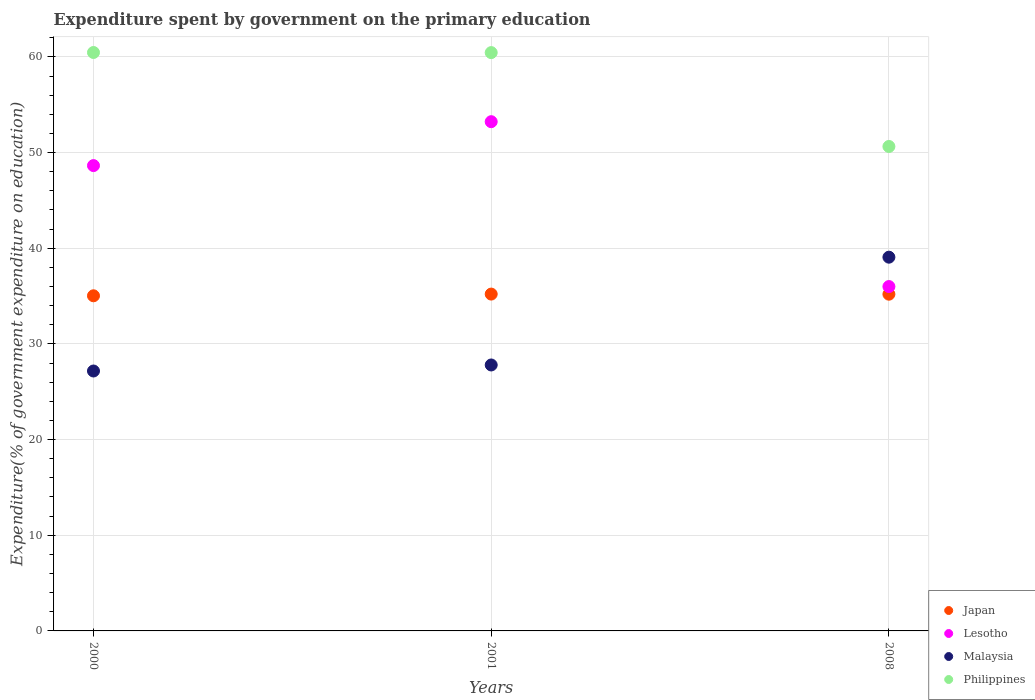Is the number of dotlines equal to the number of legend labels?
Ensure brevity in your answer.  Yes. What is the expenditure spent by government on the primary education in Malaysia in 2001?
Ensure brevity in your answer.  27.8. Across all years, what is the maximum expenditure spent by government on the primary education in Japan?
Offer a terse response. 35.21. Across all years, what is the minimum expenditure spent by government on the primary education in Philippines?
Give a very brief answer. 50.64. What is the total expenditure spent by government on the primary education in Lesotho in the graph?
Your answer should be very brief. 137.86. What is the difference between the expenditure spent by government on the primary education in Lesotho in 2000 and that in 2008?
Ensure brevity in your answer.  12.64. What is the difference between the expenditure spent by government on the primary education in Japan in 2001 and the expenditure spent by government on the primary education in Philippines in 2008?
Keep it short and to the point. -15.43. What is the average expenditure spent by government on the primary education in Lesotho per year?
Give a very brief answer. 45.95. In the year 2008, what is the difference between the expenditure spent by government on the primary education in Japan and expenditure spent by government on the primary education in Philippines?
Make the answer very short. -15.44. In how many years, is the expenditure spent by government on the primary education in Lesotho greater than 2 %?
Provide a short and direct response. 3. What is the ratio of the expenditure spent by government on the primary education in Malaysia in 2001 to that in 2008?
Keep it short and to the point. 0.71. Is the difference between the expenditure spent by government on the primary education in Japan in 2000 and 2008 greater than the difference between the expenditure spent by government on the primary education in Philippines in 2000 and 2008?
Your response must be concise. No. What is the difference between the highest and the second highest expenditure spent by government on the primary education in Japan?
Your answer should be compact. 0.01. What is the difference between the highest and the lowest expenditure spent by government on the primary education in Philippines?
Provide a succinct answer. 9.82. Is the sum of the expenditure spent by government on the primary education in Lesotho in 2001 and 2008 greater than the maximum expenditure spent by government on the primary education in Philippines across all years?
Your answer should be compact. Yes. Is the expenditure spent by government on the primary education in Philippines strictly greater than the expenditure spent by government on the primary education in Lesotho over the years?
Keep it short and to the point. Yes. Is the expenditure spent by government on the primary education in Malaysia strictly less than the expenditure spent by government on the primary education in Philippines over the years?
Your answer should be very brief. Yes. How many dotlines are there?
Your answer should be compact. 4. What is the difference between two consecutive major ticks on the Y-axis?
Your answer should be very brief. 10. Are the values on the major ticks of Y-axis written in scientific E-notation?
Your response must be concise. No. Does the graph contain grids?
Your answer should be compact. Yes. How many legend labels are there?
Provide a short and direct response. 4. What is the title of the graph?
Give a very brief answer. Expenditure spent by government on the primary education. What is the label or title of the X-axis?
Make the answer very short. Years. What is the label or title of the Y-axis?
Your answer should be very brief. Expenditure(% of government expenditure on education). What is the Expenditure(% of government expenditure on education) of Japan in 2000?
Make the answer very short. 35.03. What is the Expenditure(% of government expenditure on education) in Lesotho in 2000?
Provide a short and direct response. 48.64. What is the Expenditure(% of government expenditure on education) of Malaysia in 2000?
Your response must be concise. 27.17. What is the Expenditure(% of government expenditure on education) in Philippines in 2000?
Your answer should be compact. 60.46. What is the Expenditure(% of government expenditure on education) of Japan in 2001?
Offer a very short reply. 35.21. What is the Expenditure(% of government expenditure on education) in Lesotho in 2001?
Make the answer very short. 53.23. What is the Expenditure(% of government expenditure on education) in Malaysia in 2001?
Give a very brief answer. 27.8. What is the Expenditure(% of government expenditure on education) in Philippines in 2001?
Keep it short and to the point. 60.45. What is the Expenditure(% of government expenditure on education) in Japan in 2008?
Your answer should be compact. 35.2. What is the Expenditure(% of government expenditure on education) in Lesotho in 2008?
Give a very brief answer. 35.99. What is the Expenditure(% of government expenditure on education) in Malaysia in 2008?
Provide a short and direct response. 39.06. What is the Expenditure(% of government expenditure on education) in Philippines in 2008?
Provide a succinct answer. 50.64. Across all years, what is the maximum Expenditure(% of government expenditure on education) in Japan?
Provide a short and direct response. 35.21. Across all years, what is the maximum Expenditure(% of government expenditure on education) in Lesotho?
Make the answer very short. 53.23. Across all years, what is the maximum Expenditure(% of government expenditure on education) in Malaysia?
Offer a terse response. 39.06. Across all years, what is the maximum Expenditure(% of government expenditure on education) of Philippines?
Offer a terse response. 60.46. Across all years, what is the minimum Expenditure(% of government expenditure on education) of Japan?
Ensure brevity in your answer.  35.03. Across all years, what is the minimum Expenditure(% of government expenditure on education) in Lesotho?
Provide a succinct answer. 35.99. Across all years, what is the minimum Expenditure(% of government expenditure on education) in Malaysia?
Ensure brevity in your answer.  27.17. Across all years, what is the minimum Expenditure(% of government expenditure on education) of Philippines?
Your answer should be very brief. 50.64. What is the total Expenditure(% of government expenditure on education) of Japan in the graph?
Provide a short and direct response. 105.43. What is the total Expenditure(% of government expenditure on education) in Lesotho in the graph?
Offer a very short reply. 137.86. What is the total Expenditure(% of government expenditure on education) of Malaysia in the graph?
Your response must be concise. 94.03. What is the total Expenditure(% of government expenditure on education) of Philippines in the graph?
Your response must be concise. 171.54. What is the difference between the Expenditure(% of government expenditure on education) in Japan in 2000 and that in 2001?
Your response must be concise. -0.18. What is the difference between the Expenditure(% of government expenditure on education) of Lesotho in 2000 and that in 2001?
Offer a very short reply. -4.59. What is the difference between the Expenditure(% of government expenditure on education) of Malaysia in 2000 and that in 2001?
Your response must be concise. -0.63. What is the difference between the Expenditure(% of government expenditure on education) of Philippines in 2000 and that in 2001?
Ensure brevity in your answer.  0.01. What is the difference between the Expenditure(% of government expenditure on education) of Japan in 2000 and that in 2008?
Offer a terse response. -0.17. What is the difference between the Expenditure(% of government expenditure on education) in Lesotho in 2000 and that in 2008?
Make the answer very short. 12.64. What is the difference between the Expenditure(% of government expenditure on education) in Malaysia in 2000 and that in 2008?
Ensure brevity in your answer.  -11.9. What is the difference between the Expenditure(% of government expenditure on education) in Philippines in 2000 and that in 2008?
Provide a succinct answer. 9.82. What is the difference between the Expenditure(% of government expenditure on education) in Japan in 2001 and that in 2008?
Give a very brief answer. 0.01. What is the difference between the Expenditure(% of government expenditure on education) in Lesotho in 2001 and that in 2008?
Make the answer very short. 17.23. What is the difference between the Expenditure(% of government expenditure on education) in Malaysia in 2001 and that in 2008?
Offer a terse response. -11.27. What is the difference between the Expenditure(% of government expenditure on education) of Philippines in 2001 and that in 2008?
Offer a very short reply. 9.81. What is the difference between the Expenditure(% of government expenditure on education) in Japan in 2000 and the Expenditure(% of government expenditure on education) in Lesotho in 2001?
Offer a very short reply. -18.2. What is the difference between the Expenditure(% of government expenditure on education) of Japan in 2000 and the Expenditure(% of government expenditure on education) of Malaysia in 2001?
Provide a short and direct response. 7.23. What is the difference between the Expenditure(% of government expenditure on education) of Japan in 2000 and the Expenditure(% of government expenditure on education) of Philippines in 2001?
Give a very brief answer. -25.42. What is the difference between the Expenditure(% of government expenditure on education) of Lesotho in 2000 and the Expenditure(% of government expenditure on education) of Malaysia in 2001?
Your answer should be very brief. 20.84. What is the difference between the Expenditure(% of government expenditure on education) in Lesotho in 2000 and the Expenditure(% of government expenditure on education) in Philippines in 2001?
Your answer should be compact. -11.81. What is the difference between the Expenditure(% of government expenditure on education) of Malaysia in 2000 and the Expenditure(% of government expenditure on education) of Philippines in 2001?
Keep it short and to the point. -33.28. What is the difference between the Expenditure(% of government expenditure on education) of Japan in 2000 and the Expenditure(% of government expenditure on education) of Lesotho in 2008?
Ensure brevity in your answer.  -0.97. What is the difference between the Expenditure(% of government expenditure on education) of Japan in 2000 and the Expenditure(% of government expenditure on education) of Malaysia in 2008?
Your answer should be very brief. -4.04. What is the difference between the Expenditure(% of government expenditure on education) of Japan in 2000 and the Expenditure(% of government expenditure on education) of Philippines in 2008?
Your answer should be very brief. -15.61. What is the difference between the Expenditure(% of government expenditure on education) of Lesotho in 2000 and the Expenditure(% of government expenditure on education) of Malaysia in 2008?
Your answer should be compact. 9.57. What is the difference between the Expenditure(% of government expenditure on education) of Lesotho in 2000 and the Expenditure(% of government expenditure on education) of Philippines in 2008?
Offer a very short reply. -2. What is the difference between the Expenditure(% of government expenditure on education) in Malaysia in 2000 and the Expenditure(% of government expenditure on education) in Philippines in 2008?
Offer a very short reply. -23.47. What is the difference between the Expenditure(% of government expenditure on education) of Japan in 2001 and the Expenditure(% of government expenditure on education) of Lesotho in 2008?
Keep it short and to the point. -0.79. What is the difference between the Expenditure(% of government expenditure on education) of Japan in 2001 and the Expenditure(% of government expenditure on education) of Malaysia in 2008?
Offer a very short reply. -3.86. What is the difference between the Expenditure(% of government expenditure on education) of Japan in 2001 and the Expenditure(% of government expenditure on education) of Philippines in 2008?
Give a very brief answer. -15.43. What is the difference between the Expenditure(% of government expenditure on education) of Lesotho in 2001 and the Expenditure(% of government expenditure on education) of Malaysia in 2008?
Provide a short and direct response. 14.16. What is the difference between the Expenditure(% of government expenditure on education) in Lesotho in 2001 and the Expenditure(% of government expenditure on education) in Philippines in 2008?
Give a very brief answer. 2.59. What is the difference between the Expenditure(% of government expenditure on education) in Malaysia in 2001 and the Expenditure(% of government expenditure on education) in Philippines in 2008?
Your answer should be very brief. -22.84. What is the average Expenditure(% of government expenditure on education) in Japan per year?
Keep it short and to the point. 35.14. What is the average Expenditure(% of government expenditure on education) of Lesotho per year?
Provide a succinct answer. 45.95. What is the average Expenditure(% of government expenditure on education) in Malaysia per year?
Offer a very short reply. 31.34. What is the average Expenditure(% of government expenditure on education) of Philippines per year?
Your answer should be compact. 57.18. In the year 2000, what is the difference between the Expenditure(% of government expenditure on education) in Japan and Expenditure(% of government expenditure on education) in Lesotho?
Provide a succinct answer. -13.61. In the year 2000, what is the difference between the Expenditure(% of government expenditure on education) in Japan and Expenditure(% of government expenditure on education) in Malaysia?
Make the answer very short. 7.86. In the year 2000, what is the difference between the Expenditure(% of government expenditure on education) in Japan and Expenditure(% of government expenditure on education) in Philippines?
Give a very brief answer. -25.43. In the year 2000, what is the difference between the Expenditure(% of government expenditure on education) of Lesotho and Expenditure(% of government expenditure on education) of Malaysia?
Give a very brief answer. 21.47. In the year 2000, what is the difference between the Expenditure(% of government expenditure on education) in Lesotho and Expenditure(% of government expenditure on education) in Philippines?
Provide a short and direct response. -11.82. In the year 2000, what is the difference between the Expenditure(% of government expenditure on education) of Malaysia and Expenditure(% of government expenditure on education) of Philippines?
Keep it short and to the point. -33.29. In the year 2001, what is the difference between the Expenditure(% of government expenditure on education) in Japan and Expenditure(% of government expenditure on education) in Lesotho?
Provide a succinct answer. -18.02. In the year 2001, what is the difference between the Expenditure(% of government expenditure on education) in Japan and Expenditure(% of government expenditure on education) in Malaysia?
Your response must be concise. 7.41. In the year 2001, what is the difference between the Expenditure(% of government expenditure on education) of Japan and Expenditure(% of government expenditure on education) of Philippines?
Provide a succinct answer. -25.24. In the year 2001, what is the difference between the Expenditure(% of government expenditure on education) in Lesotho and Expenditure(% of government expenditure on education) in Malaysia?
Provide a succinct answer. 25.43. In the year 2001, what is the difference between the Expenditure(% of government expenditure on education) in Lesotho and Expenditure(% of government expenditure on education) in Philippines?
Provide a short and direct response. -7.22. In the year 2001, what is the difference between the Expenditure(% of government expenditure on education) of Malaysia and Expenditure(% of government expenditure on education) of Philippines?
Give a very brief answer. -32.65. In the year 2008, what is the difference between the Expenditure(% of government expenditure on education) in Japan and Expenditure(% of government expenditure on education) in Lesotho?
Give a very brief answer. -0.8. In the year 2008, what is the difference between the Expenditure(% of government expenditure on education) in Japan and Expenditure(% of government expenditure on education) in Malaysia?
Offer a very short reply. -3.87. In the year 2008, what is the difference between the Expenditure(% of government expenditure on education) of Japan and Expenditure(% of government expenditure on education) of Philippines?
Ensure brevity in your answer.  -15.44. In the year 2008, what is the difference between the Expenditure(% of government expenditure on education) in Lesotho and Expenditure(% of government expenditure on education) in Malaysia?
Keep it short and to the point. -3.07. In the year 2008, what is the difference between the Expenditure(% of government expenditure on education) of Lesotho and Expenditure(% of government expenditure on education) of Philippines?
Provide a succinct answer. -14.64. In the year 2008, what is the difference between the Expenditure(% of government expenditure on education) of Malaysia and Expenditure(% of government expenditure on education) of Philippines?
Ensure brevity in your answer.  -11.57. What is the ratio of the Expenditure(% of government expenditure on education) of Lesotho in 2000 to that in 2001?
Offer a terse response. 0.91. What is the ratio of the Expenditure(% of government expenditure on education) of Malaysia in 2000 to that in 2001?
Offer a terse response. 0.98. What is the ratio of the Expenditure(% of government expenditure on education) in Lesotho in 2000 to that in 2008?
Keep it short and to the point. 1.35. What is the ratio of the Expenditure(% of government expenditure on education) of Malaysia in 2000 to that in 2008?
Offer a very short reply. 0.7. What is the ratio of the Expenditure(% of government expenditure on education) in Philippines in 2000 to that in 2008?
Your answer should be compact. 1.19. What is the ratio of the Expenditure(% of government expenditure on education) in Japan in 2001 to that in 2008?
Keep it short and to the point. 1. What is the ratio of the Expenditure(% of government expenditure on education) of Lesotho in 2001 to that in 2008?
Ensure brevity in your answer.  1.48. What is the ratio of the Expenditure(% of government expenditure on education) in Malaysia in 2001 to that in 2008?
Provide a succinct answer. 0.71. What is the ratio of the Expenditure(% of government expenditure on education) of Philippines in 2001 to that in 2008?
Keep it short and to the point. 1.19. What is the difference between the highest and the second highest Expenditure(% of government expenditure on education) of Japan?
Your answer should be compact. 0.01. What is the difference between the highest and the second highest Expenditure(% of government expenditure on education) of Lesotho?
Your answer should be compact. 4.59. What is the difference between the highest and the second highest Expenditure(% of government expenditure on education) in Malaysia?
Your answer should be compact. 11.27. What is the difference between the highest and the second highest Expenditure(% of government expenditure on education) in Philippines?
Your answer should be compact. 0.01. What is the difference between the highest and the lowest Expenditure(% of government expenditure on education) in Japan?
Provide a succinct answer. 0.18. What is the difference between the highest and the lowest Expenditure(% of government expenditure on education) of Lesotho?
Offer a very short reply. 17.23. What is the difference between the highest and the lowest Expenditure(% of government expenditure on education) of Malaysia?
Your response must be concise. 11.9. What is the difference between the highest and the lowest Expenditure(% of government expenditure on education) of Philippines?
Offer a terse response. 9.82. 